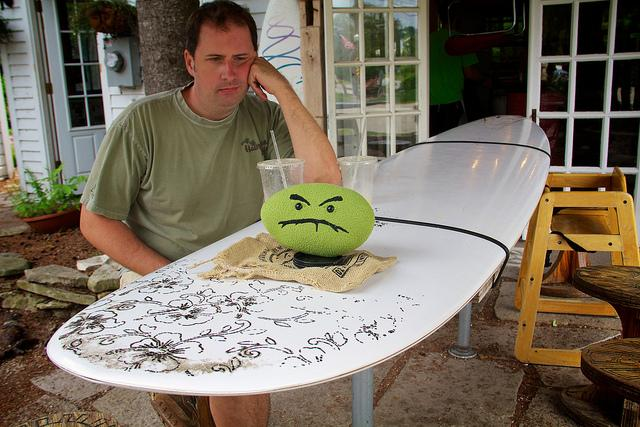What facial expression is the green ball showing? Please explain your reasoning. anger. The mouth lines are going down at the corners and the eyebrows are also down 